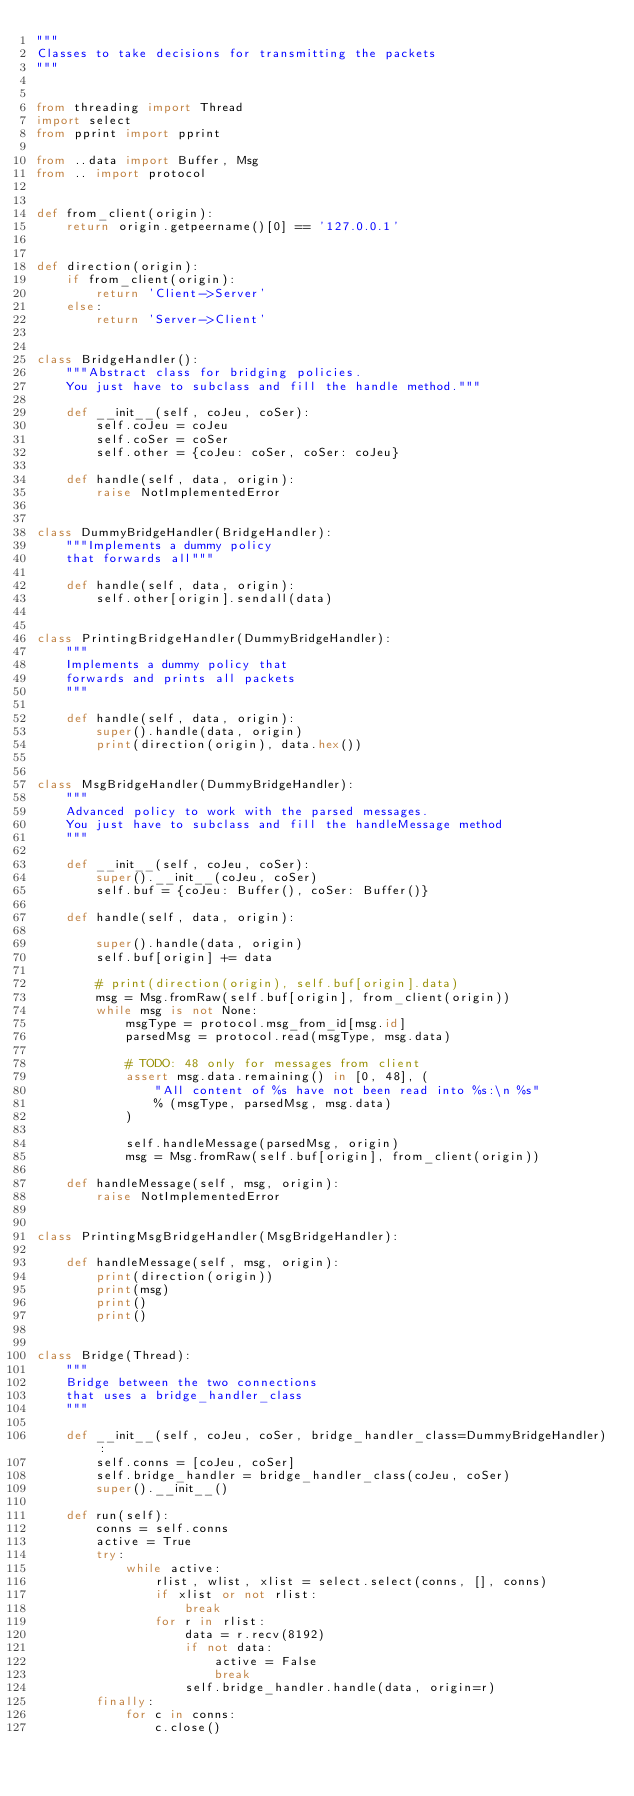<code> <loc_0><loc_0><loc_500><loc_500><_Python_>"""
Classes to take decisions for transmitting the packets
"""


from threading import Thread
import select
from pprint import pprint

from ..data import Buffer, Msg
from .. import protocol


def from_client(origin):
    return origin.getpeername()[0] == '127.0.0.1'


def direction(origin):
    if from_client(origin):
        return 'Client->Server'
    else:
        return 'Server->Client'


class BridgeHandler():
    """Abstract class for bridging policies.
    You just have to subclass and fill the handle method."""

    def __init__(self, coJeu, coSer):
        self.coJeu = coJeu
        self.coSer = coSer
        self.other = {coJeu: coSer, coSer: coJeu}

    def handle(self, data, origin):
        raise NotImplementedError


class DummyBridgeHandler(BridgeHandler):
    """Implements a dummy policy
    that forwards all"""

    def handle(self, data, origin):
        self.other[origin].sendall(data)


class PrintingBridgeHandler(DummyBridgeHandler):
    """
    Implements a dummy policy that
    forwards and prints all packets
    """

    def handle(self, data, origin):
        super().handle(data, origin)
        print(direction(origin), data.hex())


class MsgBridgeHandler(DummyBridgeHandler):
    """
    Advanced policy to work with the parsed messages.
    You just have to subclass and fill the handleMessage method
    """

    def __init__(self, coJeu, coSer):
        super().__init__(coJeu, coSer)
        self.buf = {coJeu: Buffer(), coSer: Buffer()}
        
    def handle(self, data, origin):
        
        super().handle(data, origin)
        self.buf[origin] += data        
        
        # print(direction(origin), self.buf[origin].data)
        msg = Msg.fromRaw(self.buf[origin], from_client(origin))
        while msg is not None:
            msgType = protocol.msg_from_id[msg.id]
            parsedMsg = protocol.read(msgType, msg.data)
            
            # TODO: 48 only for messages from client
            assert msg.data.remaining() in [0, 48], (
                "All content of %s have not been read into %s:\n %s"
                % (msgType, parsedMsg, msg.data)
            )
            
            self.handleMessage(parsedMsg, origin)
            msg = Msg.fromRaw(self.buf[origin], from_client(origin))

    def handleMessage(self, msg, origin):
        raise NotImplementedError


class PrintingMsgBridgeHandler(MsgBridgeHandler):

    def handleMessage(self, msg, origin):
        print(direction(origin))
        print(msg)
        print()
        print()


class Bridge(Thread):
    """
    Bridge between the two connections
    that uses a bridge_handler_class
    """

    def __init__(self, coJeu, coSer, bridge_handler_class=DummyBridgeHandler):
        self.conns = [coJeu, coSer]
        self.bridge_handler = bridge_handler_class(coJeu, coSer)
        super().__init__()

    def run(self):
        conns = self.conns
        active = True
        try:
            while active:
                rlist, wlist, xlist = select.select(conns, [], conns)
                if xlist or not rlist:
                    break
                for r in rlist:
                    data = r.recv(8192)
                    if not data:
                        active = False
                        break
                    self.bridge_handler.handle(data, origin=r)
        finally:
            for c in conns:
                c.close()
</code> 